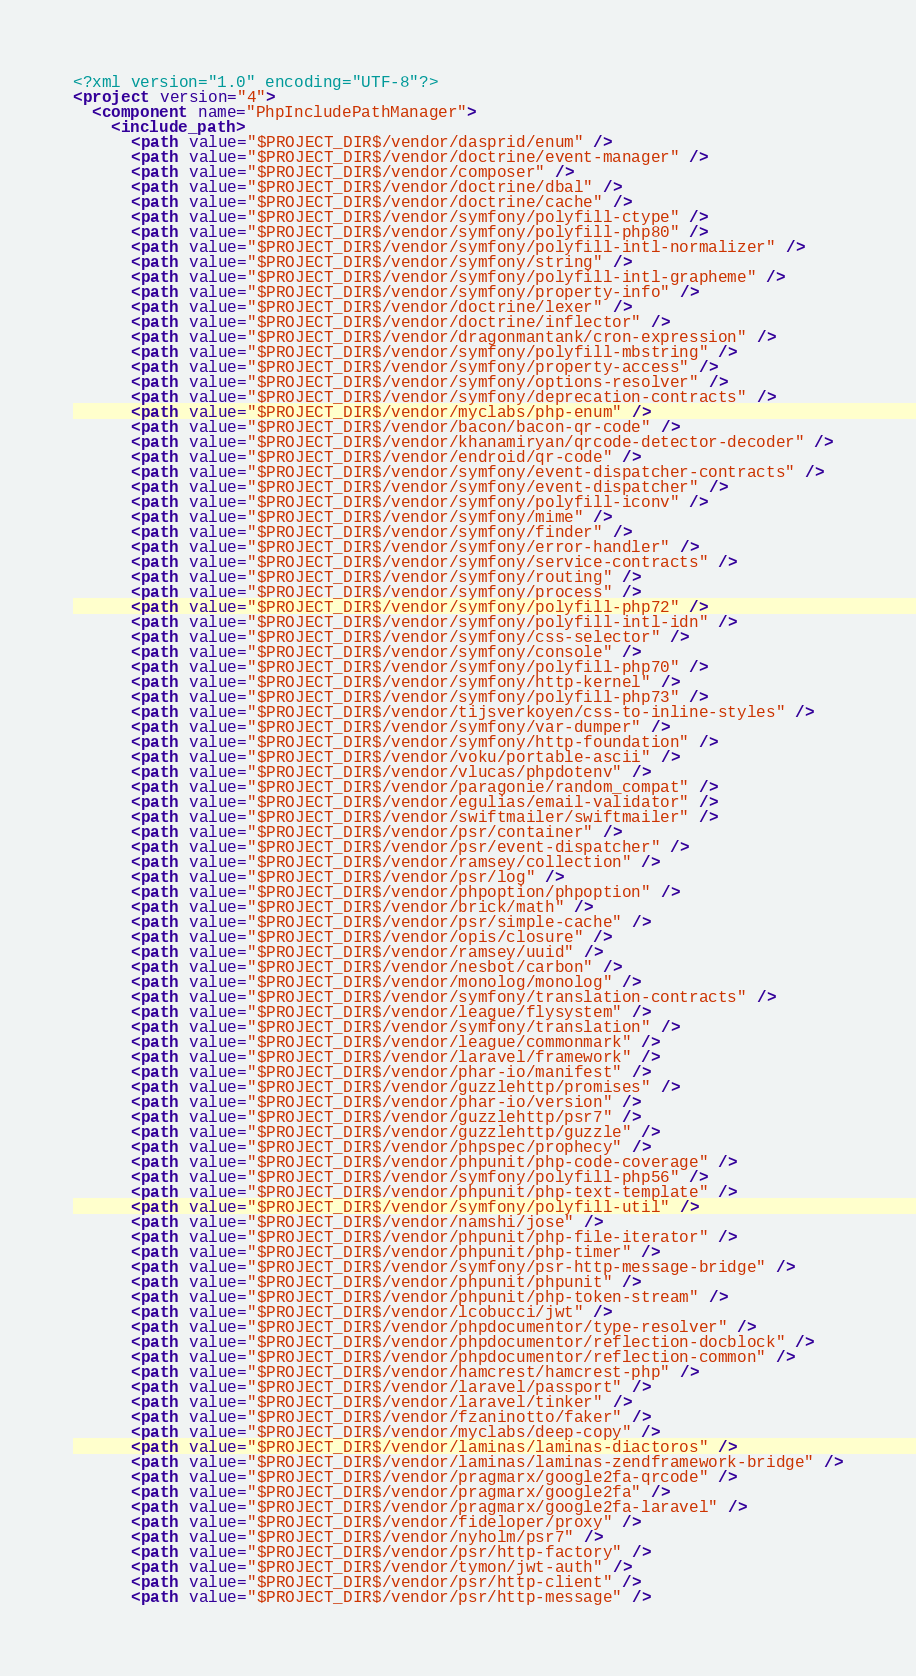<code> <loc_0><loc_0><loc_500><loc_500><_XML_><?xml version="1.0" encoding="UTF-8"?>
<project version="4">
  <component name="PhpIncludePathManager">
    <include_path>
      <path value="$PROJECT_DIR$/vendor/dasprid/enum" />
      <path value="$PROJECT_DIR$/vendor/doctrine/event-manager" />
      <path value="$PROJECT_DIR$/vendor/composer" />
      <path value="$PROJECT_DIR$/vendor/doctrine/dbal" />
      <path value="$PROJECT_DIR$/vendor/doctrine/cache" />
      <path value="$PROJECT_DIR$/vendor/symfony/polyfill-ctype" />
      <path value="$PROJECT_DIR$/vendor/symfony/polyfill-php80" />
      <path value="$PROJECT_DIR$/vendor/symfony/polyfill-intl-normalizer" />
      <path value="$PROJECT_DIR$/vendor/symfony/string" />
      <path value="$PROJECT_DIR$/vendor/symfony/polyfill-intl-grapheme" />
      <path value="$PROJECT_DIR$/vendor/symfony/property-info" />
      <path value="$PROJECT_DIR$/vendor/doctrine/lexer" />
      <path value="$PROJECT_DIR$/vendor/doctrine/inflector" />
      <path value="$PROJECT_DIR$/vendor/dragonmantank/cron-expression" />
      <path value="$PROJECT_DIR$/vendor/symfony/polyfill-mbstring" />
      <path value="$PROJECT_DIR$/vendor/symfony/property-access" />
      <path value="$PROJECT_DIR$/vendor/symfony/options-resolver" />
      <path value="$PROJECT_DIR$/vendor/symfony/deprecation-contracts" />
      <path value="$PROJECT_DIR$/vendor/myclabs/php-enum" />
      <path value="$PROJECT_DIR$/vendor/bacon/bacon-qr-code" />
      <path value="$PROJECT_DIR$/vendor/khanamiryan/qrcode-detector-decoder" />
      <path value="$PROJECT_DIR$/vendor/endroid/qr-code" />
      <path value="$PROJECT_DIR$/vendor/symfony/event-dispatcher-contracts" />
      <path value="$PROJECT_DIR$/vendor/symfony/event-dispatcher" />
      <path value="$PROJECT_DIR$/vendor/symfony/polyfill-iconv" />
      <path value="$PROJECT_DIR$/vendor/symfony/mime" />
      <path value="$PROJECT_DIR$/vendor/symfony/finder" />
      <path value="$PROJECT_DIR$/vendor/symfony/error-handler" />
      <path value="$PROJECT_DIR$/vendor/symfony/service-contracts" />
      <path value="$PROJECT_DIR$/vendor/symfony/routing" />
      <path value="$PROJECT_DIR$/vendor/symfony/process" />
      <path value="$PROJECT_DIR$/vendor/symfony/polyfill-php72" />
      <path value="$PROJECT_DIR$/vendor/symfony/polyfill-intl-idn" />
      <path value="$PROJECT_DIR$/vendor/symfony/css-selector" />
      <path value="$PROJECT_DIR$/vendor/symfony/console" />
      <path value="$PROJECT_DIR$/vendor/symfony/polyfill-php70" />
      <path value="$PROJECT_DIR$/vendor/symfony/http-kernel" />
      <path value="$PROJECT_DIR$/vendor/symfony/polyfill-php73" />
      <path value="$PROJECT_DIR$/vendor/tijsverkoyen/css-to-inline-styles" />
      <path value="$PROJECT_DIR$/vendor/symfony/var-dumper" />
      <path value="$PROJECT_DIR$/vendor/symfony/http-foundation" />
      <path value="$PROJECT_DIR$/vendor/voku/portable-ascii" />
      <path value="$PROJECT_DIR$/vendor/vlucas/phpdotenv" />
      <path value="$PROJECT_DIR$/vendor/paragonie/random_compat" />
      <path value="$PROJECT_DIR$/vendor/egulias/email-validator" />
      <path value="$PROJECT_DIR$/vendor/swiftmailer/swiftmailer" />
      <path value="$PROJECT_DIR$/vendor/psr/container" />
      <path value="$PROJECT_DIR$/vendor/psr/event-dispatcher" />
      <path value="$PROJECT_DIR$/vendor/ramsey/collection" />
      <path value="$PROJECT_DIR$/vendor/psr/log" />
      <path value="$PROJECT_DIR$/vendor/phpoption/phpoption" />
      <path value="$PROJECT_DIR$/vendor/brick/math" />
      <path value="$PROJECT_DIR$/vendor/psr/simple-cache" />
      <path value="$PROJECT_DIR$/vendor/opis/closure" />
      <path value="$PROJECT_DIR$/vendor/ramsey/uuid" />
      <path value="$PROJECT_DIR$/vendor/nesbot/carbon" />
      <path value="$PROJECT_DIR$/vendor/monolog/monolog" />
      <path value="$PROJECT_DIR$/vendor/symfony/translation-contracts" />
      <path value="$PROJECT_DIR$/vendor/league/flysystem" />
      <path value="$PROJECT_DIR$/vendor/symfony/translation" />
      <path value="$PROJECT_DIR$/vendor/league/commonmark" />
      <path value="$PROJECT_DIR$/vendor/laravel/framework" />
      <path value="$PROJECT_DIR$/vendor/phar-io/manifest" />
      <path value="$PROJECT_DIR$/vendor/guzzlehttp/promises" />
      <path value="$PROJECT_DIR$/vendor/phar-io/version" />
      <path value="$PROJECT_DIR$/vendor/guzzlehttp/psr7" />
      <path value="$PROJECT_DIR$/vendor/guzzlehttp/guzzle" />
      <path value="$PROJECT_DIR$/vendor/phpspec/prophecy" />
      <path value="$PROJECT_DIR$/vendor/phpunit/php-code-coverage" />
      <path value="$PROJECT_DIR$/vendor/symfony/polyfill-php56" />
      <path value="$PROJECT_DIR$/vendor/phpunit/php-text-template" />
      <path value="$PROJECT_DIR$/vendor/symfony/polyfill-util" />
      <path value="$PROJECT_DIR$/vendor/namshi/jose" />
      <path value="$PROJECT_DIR$/vendor/phpunit/php-file-iterator" />
      <path value="$PROJECT_DIR$/vendor/phpunit/php-timer" />
      <path value="$PROJECT_DIR$/vendor/symfony/psr-http-message-bridge" />
      <path value="$PROJECT_DIR$/vendor/phpunit/phpunit" />
      <path value="$PROJECT_DIR$/vendor/phpunit/php-token-stream" />
      <path value="$PROJECT_DIR$/vendor/lcobucci/jwt" />
      <path value="$PROJECT_DIR$/vendor/phpdocumentor/type-resolver" />
      <path value="$PROJECT_DIR$/vendor/phpdocumentor/reflection-docblock" />
      <path value="$PROJECT_DIR$/vendor/phpdocumentor/reflection-common" />
      <path value="$PROJECT_DIR$/vendor/hamcrest/hamcrest-php" />
      <path value="$PROJECT_DIR$/vendor/laravel/passport" />
      <path value="$PROJECT_DIR$/vendor/laravel/tinker" />
      <path value="$PROJECT_DIR$/vendor/fzaninotto/faker" />
      <path value="$PROJECT_DIR$/vendor/myclabs/deep-copy" />
      <path value="$PROJECT_DIR$/vendor/laminas/laminas-diactoros" />
      <path value="$PROJECT_DIR$/vendor/laminas/laminas-zendframework-bridge" />
      <path value="$PROJECT_DIR$/vendor/pragmarx/google2fa-qrcode" />
      <path value="$PROJECT_DIR$/vendor/pragmarx/google2fa" />
      <path value="$PROJECT_DIR$/vendor/pragmarx/google2fa-laravel" />
      <path value="$PROJECT_DIR$/vendor/fideloper/proxy" />
      <path value="$PROJECT_DIR$/vendor/nyholm/psr7" />
      <path value="$PROJECT_DIR$/vendor/psr/http-factory" />
      <path value="$PROJECT_DIR$/vendor/tymon/jwt-auth" />
      <path value="$PROJECT_DIR$/vendor/psr/http-client" />
      <path value="$PROJECT_DIR$/vendor/psr/http-message" /></code> 